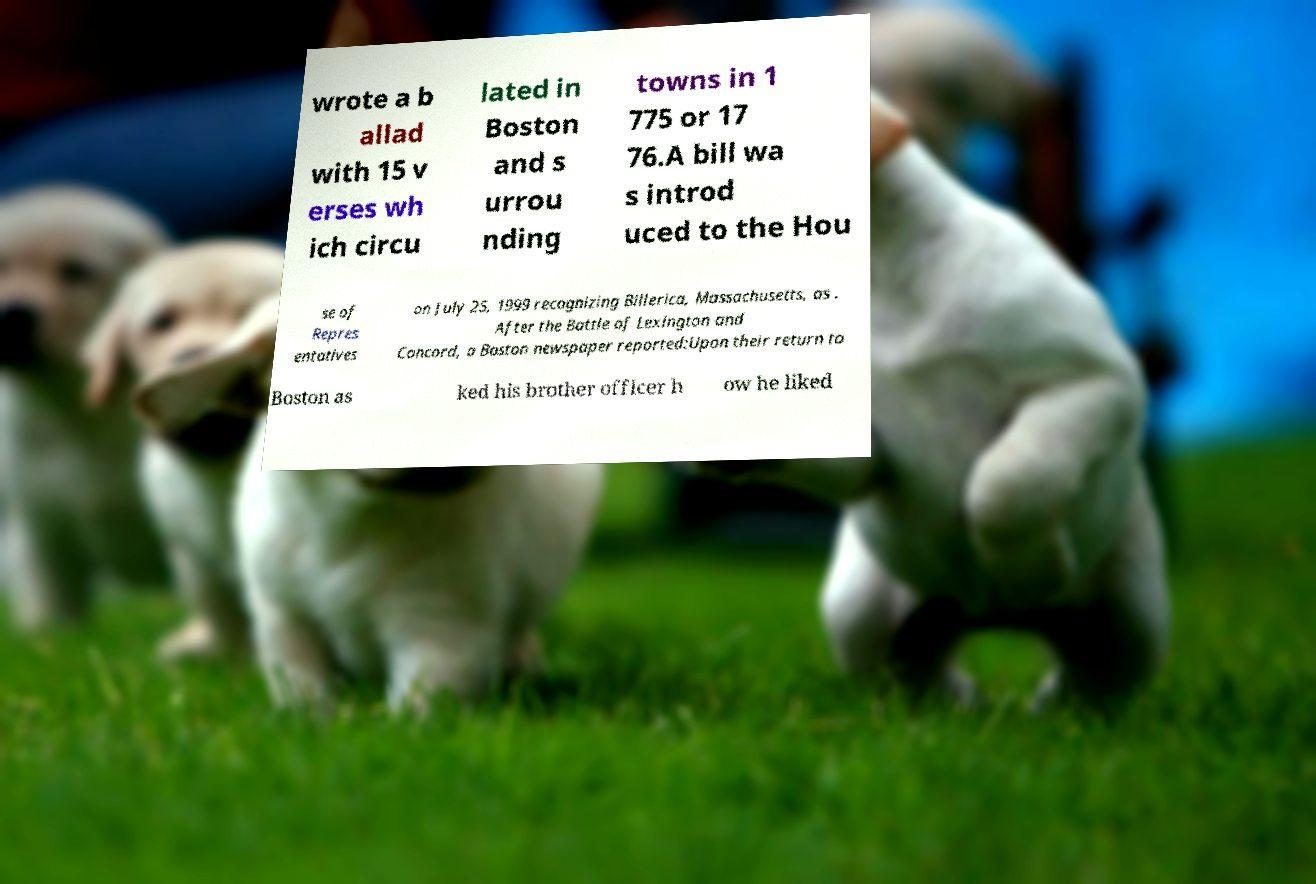Please identify and transcribe the text found in this image. wrote a b allad with 15 v erses wh ich circu lated in Boston and s urrou nding towns in 1 775 or 17 76.A bill wa s introd uced to the Hou se of Repres entatives on July 25, 1999 recognizing Billerica, Massachusetts, as . After the Battle of Lexington and Concord, a Boston newspaper reported:Upon their return to Boston as ked his brother officer h ow he liked 